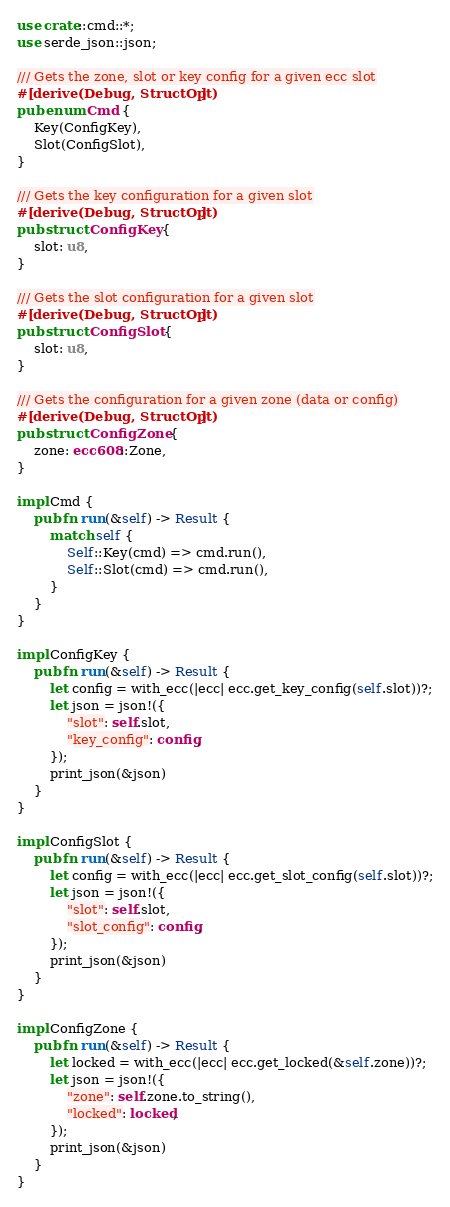Convert code to text. <code><loc_0><loc_0><loc_500><loc_500><_Rust_>use crate::cmd::*;
use serde_json::json;

/// Gets the zone, slot or key config for a given ecc slot
#[derive(Debug, StructOpt)]
pub enum Cmd {
    Key(ConfigKey),
    Slot(ConfigSlot),
}

/// Gets the key configuration for a given slot
#[derive(Debug, StructOpt)]
pub struct ConfigKey {
    slot: u8,
}

/// Gets the slot configuration for a given slot
#[derive(Debug, StructOpt)]
pub struct ConfigSlot {
    slot: u8,
}

/// Gets the configuration for a given zone (data or config)
#[derive(Debug, StructOpt)]
pub struct ConfigZone {
    zone: ecc608::Zone,
}

impl Cmd {
    pub fn run(&self) -> Result {
        match self {
            Self::Key(cmd) => cmd.run(),
            Self::Slot(cmd) => cmd.run(),
        }
    }
}

impl ConfigKey {
    pub fn run(&self) -> Result {
        let config = with_ecc(|ecc| ecc.get_key_config(self.slot))?;
        let json = json!({
            "slot": self.slot,
            "key_config": config,
        });
        print_json(&json)
    }
}

impl ConfigSlot {
    pub fn run(&self) -> Result {
        let config = with_ecc(|ecc| ecc.get_slot_config(self.slot))?;
        let json = json!({
            "slot": self.slot,
            "slot_config": config,
        });
        print_json(&json)
    }
}

impl ConfigZone {
    pub fn run(&self) -> Result {
        let locked = with_ecc(|ecc| ecc.get_locked(&self.zone))?;
        let json = json!({
            "zone": self.zone.to_string(),
            "locked": locked,
        });
        print_json(&json)
    }
}
</code> 